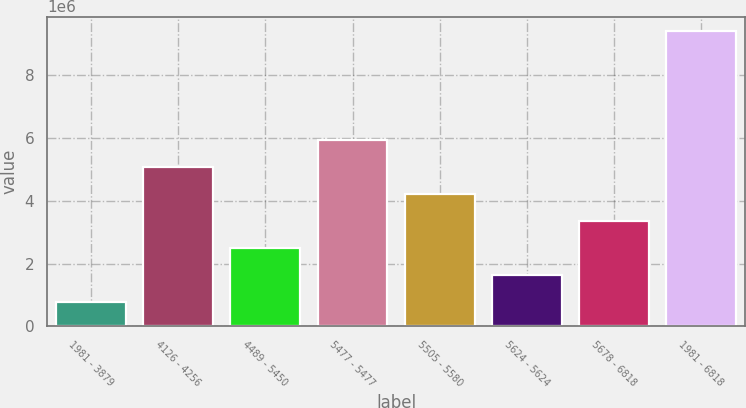Convert chart to OTSL. <chart><loc_0><loc_0><loc_500><loc_500><bar_chart><fcel>1981 - 3879<fcel>4126 - 4256<fcel>4489 - 5450<fcel>5477 - 5477<fcel>5505 - 5580<fcel>5624 - 5624<fcel>5678 - 6818<fcel>1981 - 6818<nl><fcel>773809<fcel>5.08386e+06<fcel>2.49783e+06<fcel>5.94588e+06<fcel>4.22185e+06<fcel>1.63582e+06<fcel>3.35984e+06<fcel>9.39392e+06<nl></chart> 